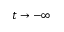Convert formula to latex. <formula><loc_0><loc_0><loc_500><loc_500>t \rightarrow - \infty</formula> 